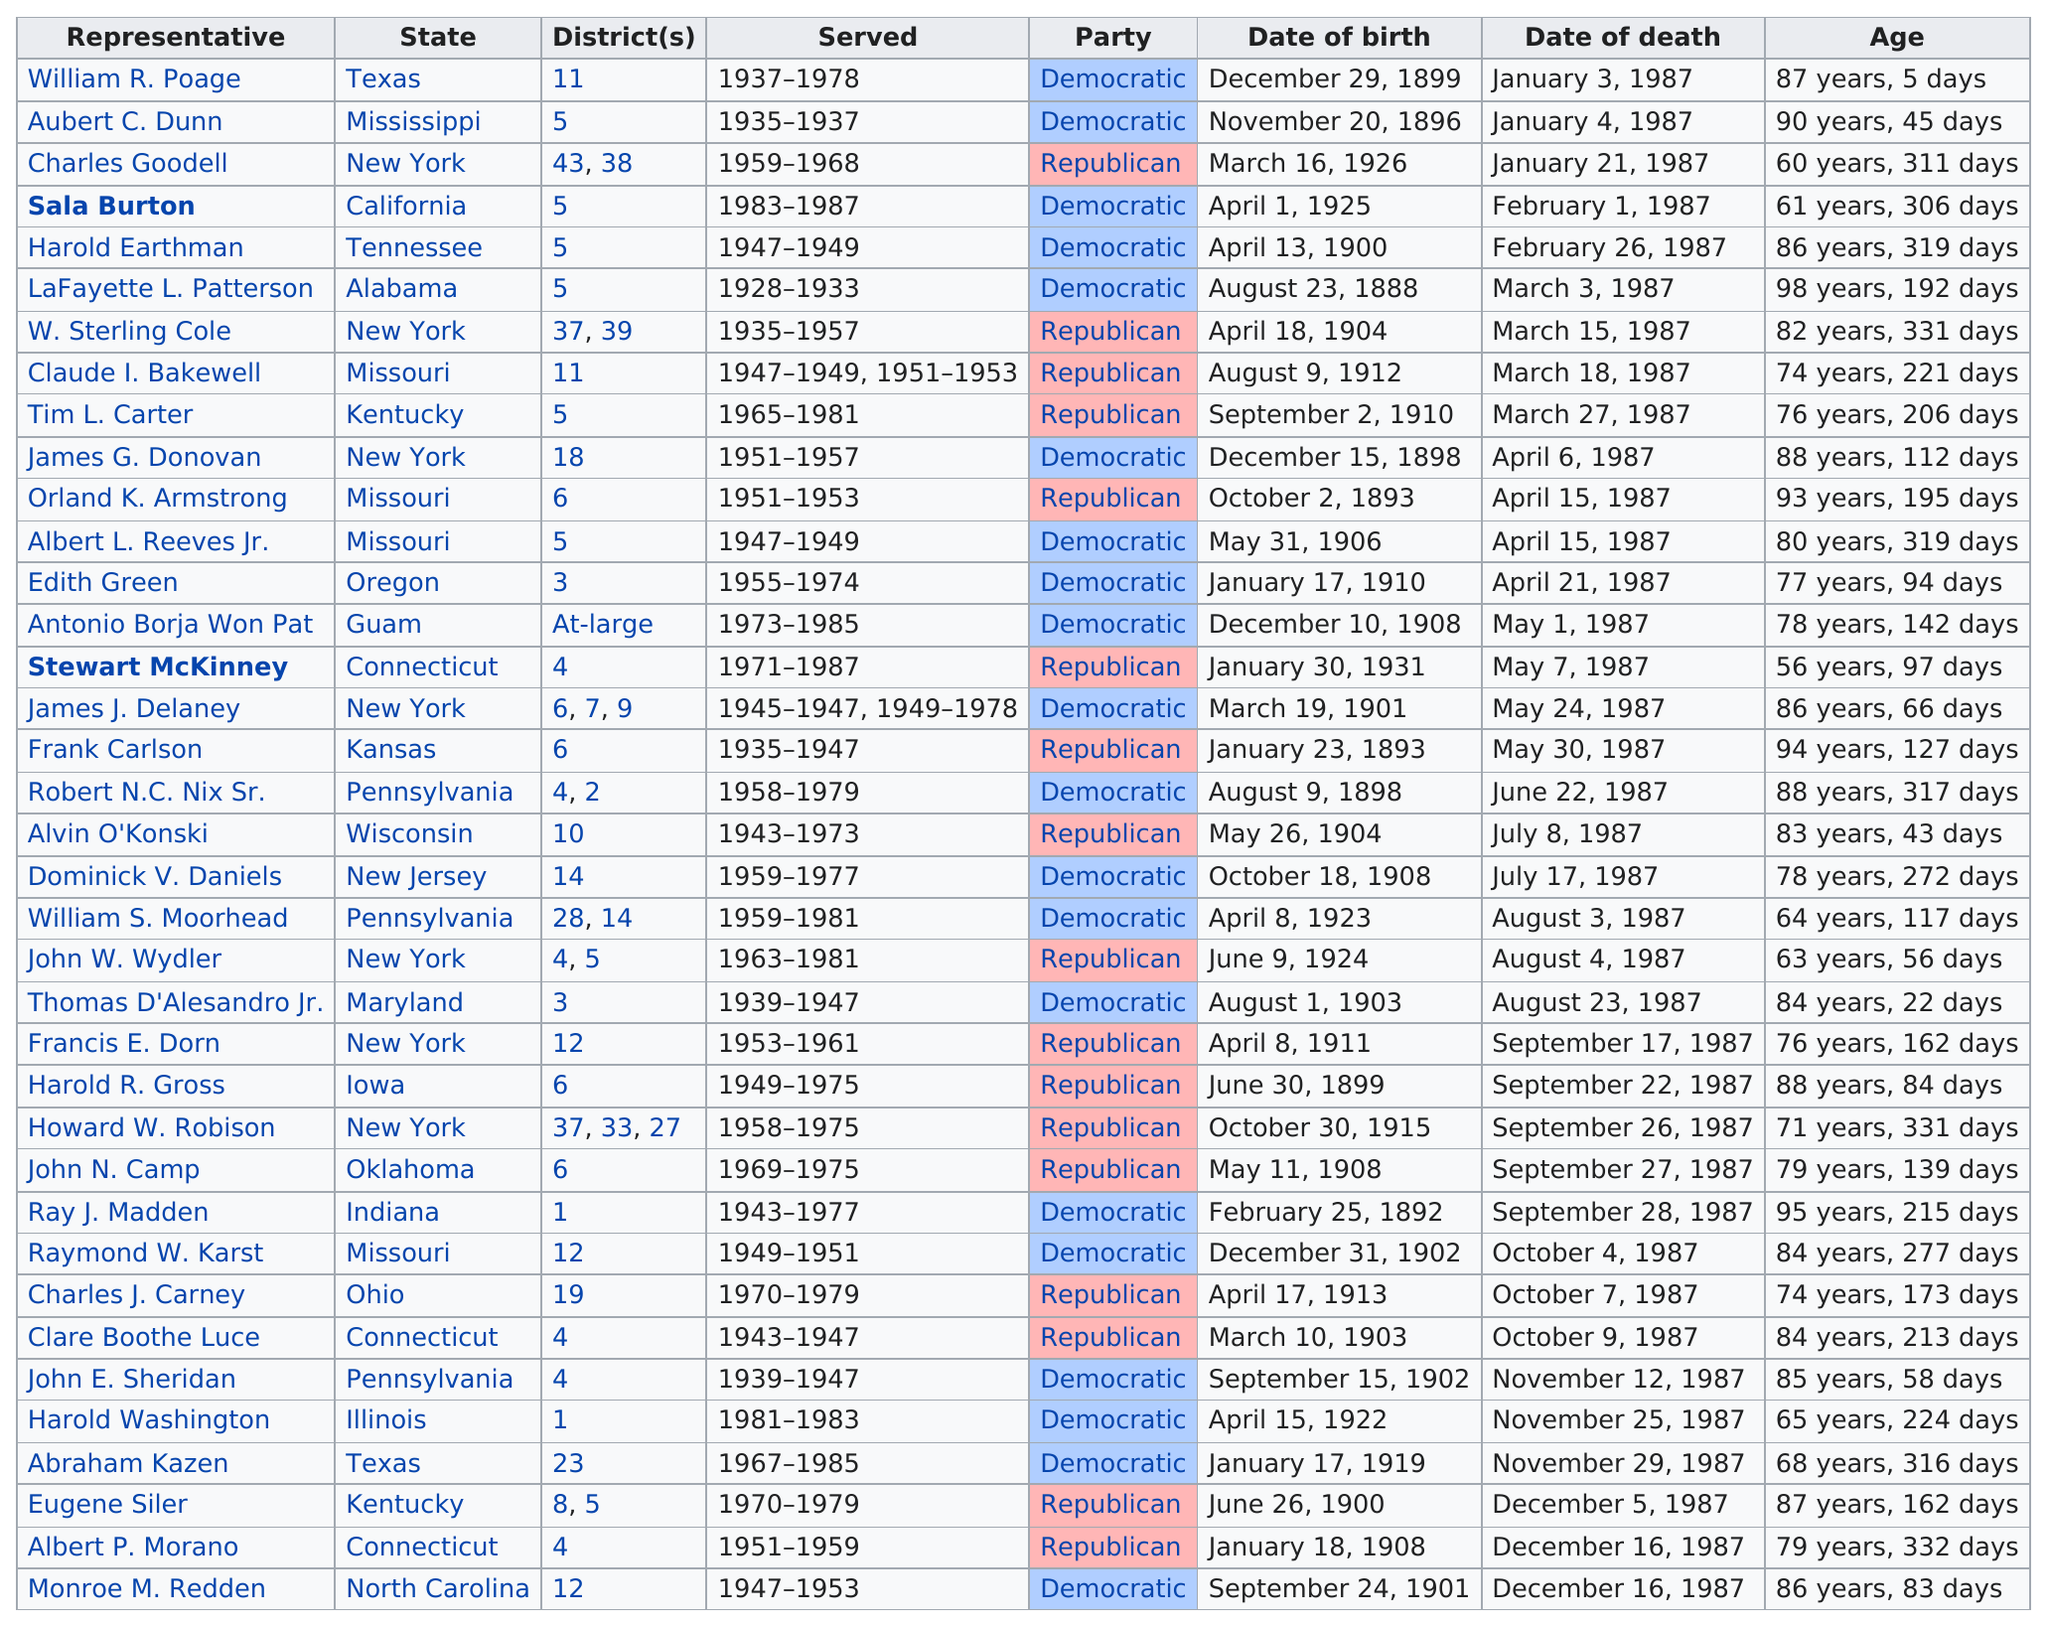Give some essential details in this illustration. Harold Earthman was older than 79 years of age. The Democratic Party has the highest number of deaths. Charles Goodell was the first death in the Republican Party. William R. Poage served in Texas for 41 years. Charles Goodell served in two districts. 